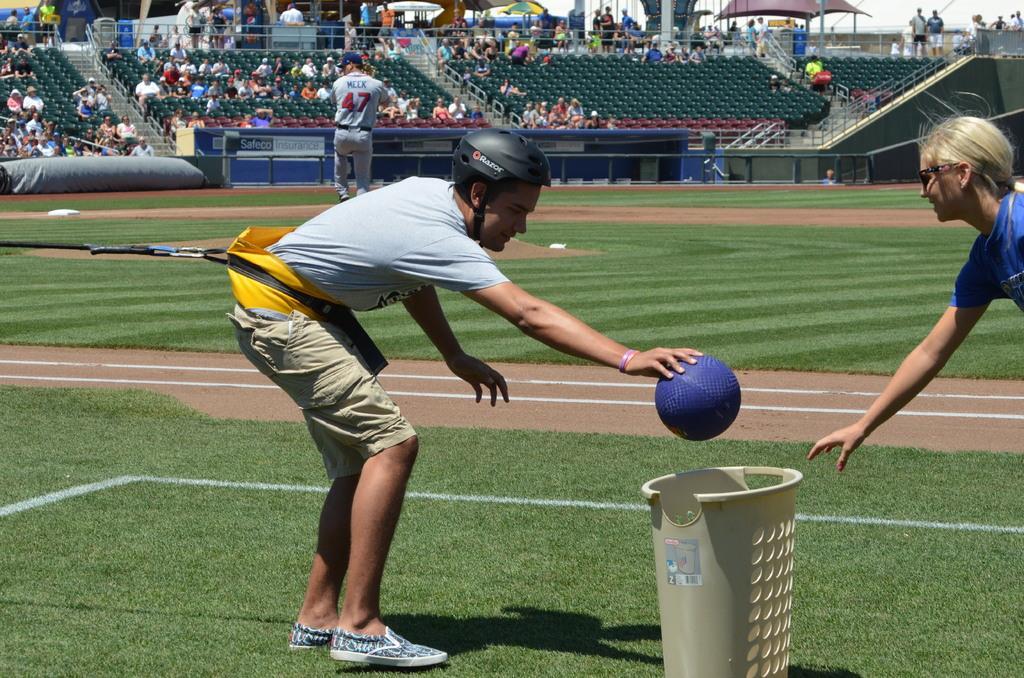Please provide a concise description of this image. In front of the image there is a person is throwing a ball in the basket in front of him, beside the basket there is another person. Behind them there is a person standing on the ground. In the background of the image there are a few spectators watching the game from the stands, behind the stands there are tents and pillars. On the left side of the image there is a rope connected to a person. 